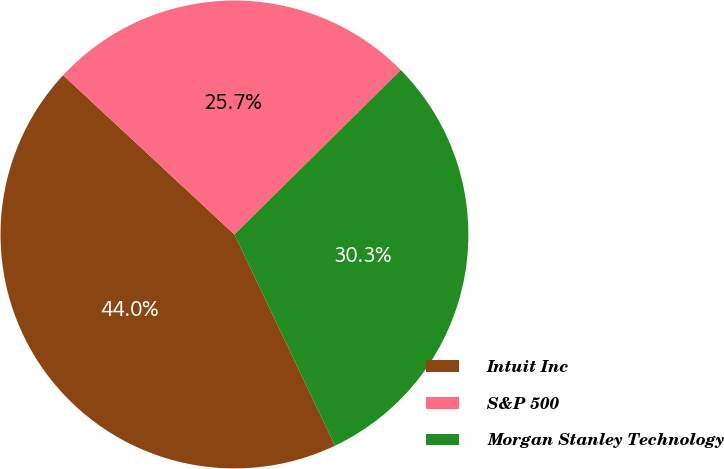<chart> <loc_0><loc_0><loc_500><loc_500><pie_chart><fcel>Intuit Inc<fcel>S&P 500<fcel>Morgan Stanley Technology<nl><fcel>43.99%<fcel>25.67%<fcel>30.33%<nl></chart> 